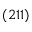Convert formula to latex. <formula><loc_0><loc_0><loc_500><loc_500>( 2 1 1 )</formula> 